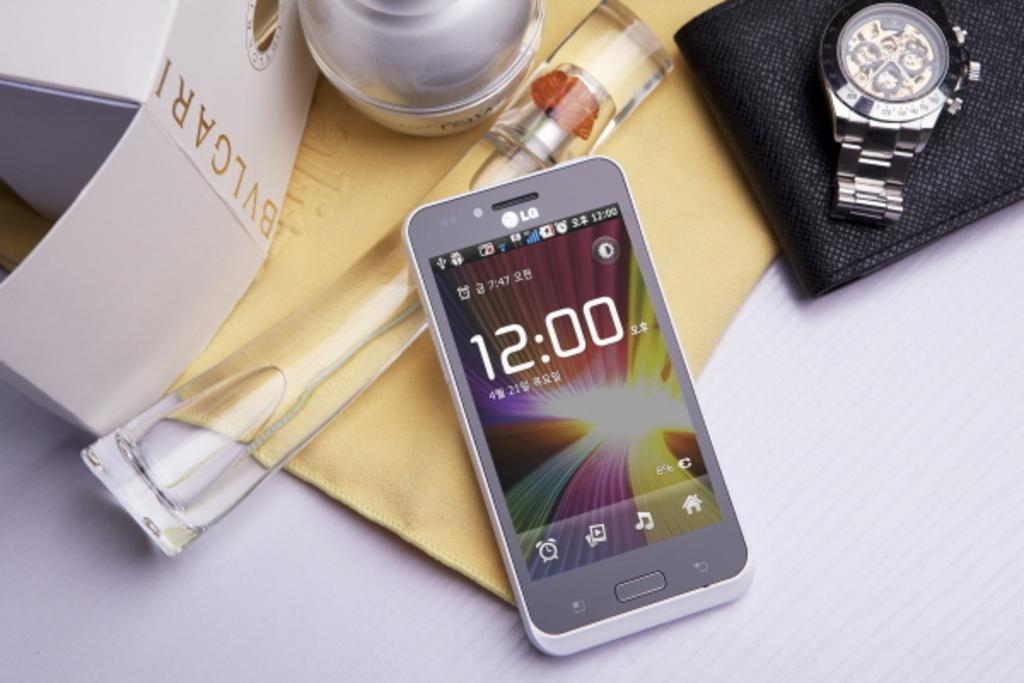<image>
Present a compact description of the photo's key features. A table with a watch and an LG phone showing the time 12:00. 